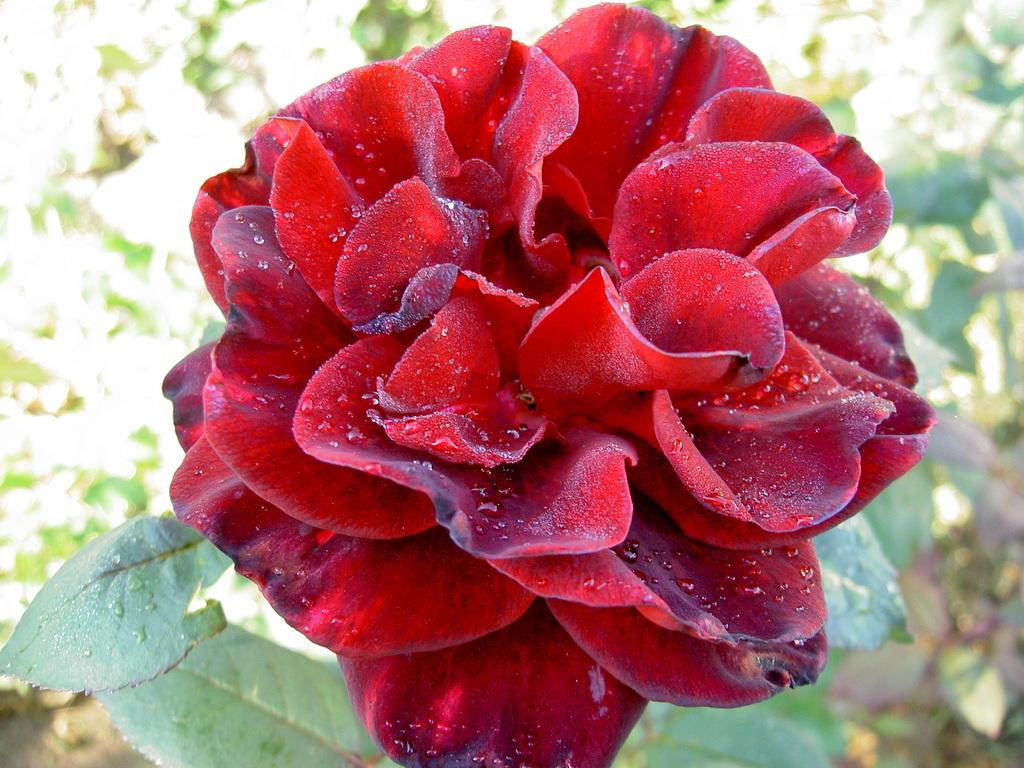What type of plant is featured in the image? There is a plant with a red flower in the image. Can you describe the surrounding plants in the image? There are other plants in the background of the image. What type of jar is holding the slave in the image? There is no jar or slave present in the image; it features a plant with a red flower and other plants in the background. 